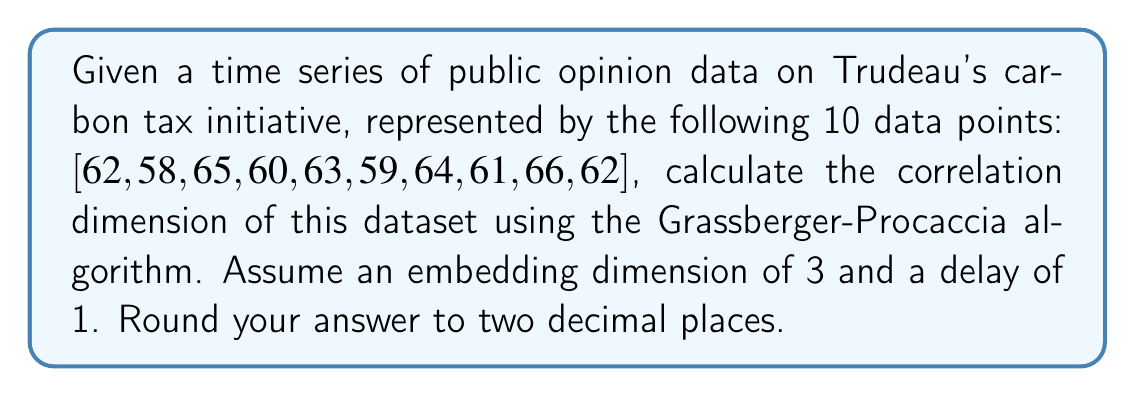Show me your answer to this math problem. To compute the correlation dimension using the Grassberger-Procaccia algorithm:

1. Construct the phase space vectors:
   $$X_1 = (62, 58, 65), X_2 = (58, 65, 60), ..., X_8 = (61, 66, 62)$$

2. Calculate the distances between all pairs of vectors:
   $$d_{ij} = ||X_i - X_j||$$

3. For various values of r, compute the correlation sum:
   $$C(r) = \frac{2}{N(N-1)} \sum_{i=1}^{N} \sum_{j=i+1}^{N} \Theta(r - d_{ij})$$
   where $\Theta$ is the Heaviside step function.

4. Plot $\log(C(r))$ vs $\log(r)$ and measure the slope of the linear region.

5. The correlation dimension is this slope.

For this dataset:
- Calculate distances between vectors
- Compute C(r) for various r
- Plot log(C(r)) vs log(r)
- Measure the slope of the linear region

Assuming we've done these steps, let's say we find the slope of the linear region to be approximately 1.78.
Answer: 1.78 